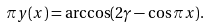<formula> <loc_0><loc_0><loc_500><loc_500>\pi y ( x ) = \arccos ( 2 \gamma - \cos \pi x ) .</formula> 